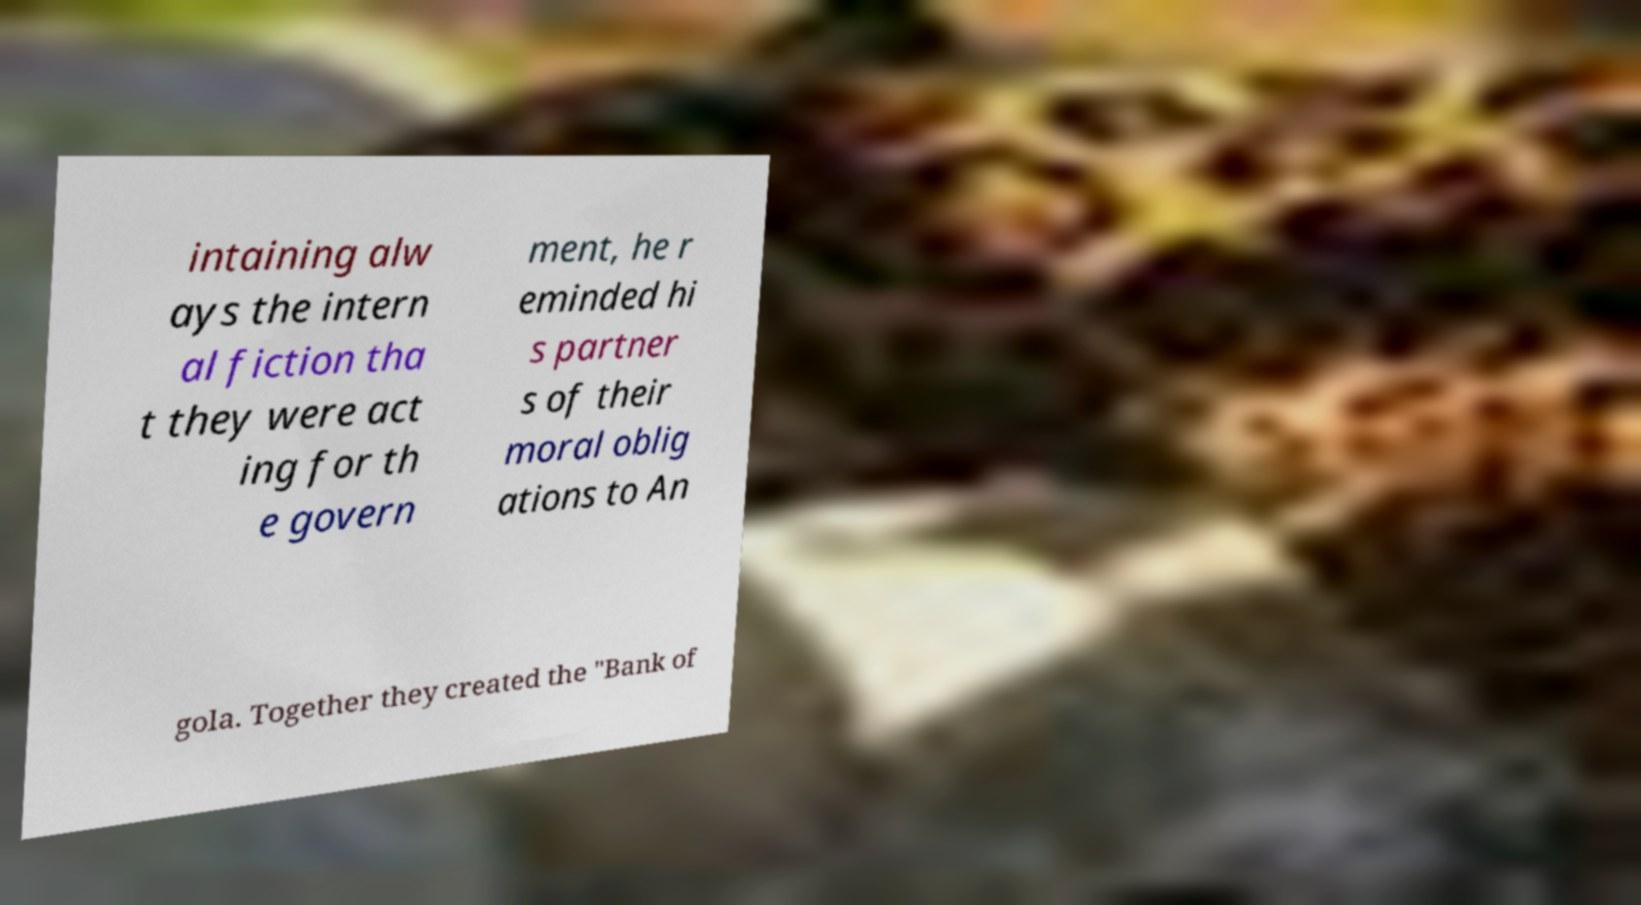Could you assist in decoding the text presented in this image and type it out clearly? intaining alw ays the intern al fiction tha t they were act ing for th e govern ment, he r eminded hi s partner s of their moral oblig ations to An gola. Together they created the "Bank of 